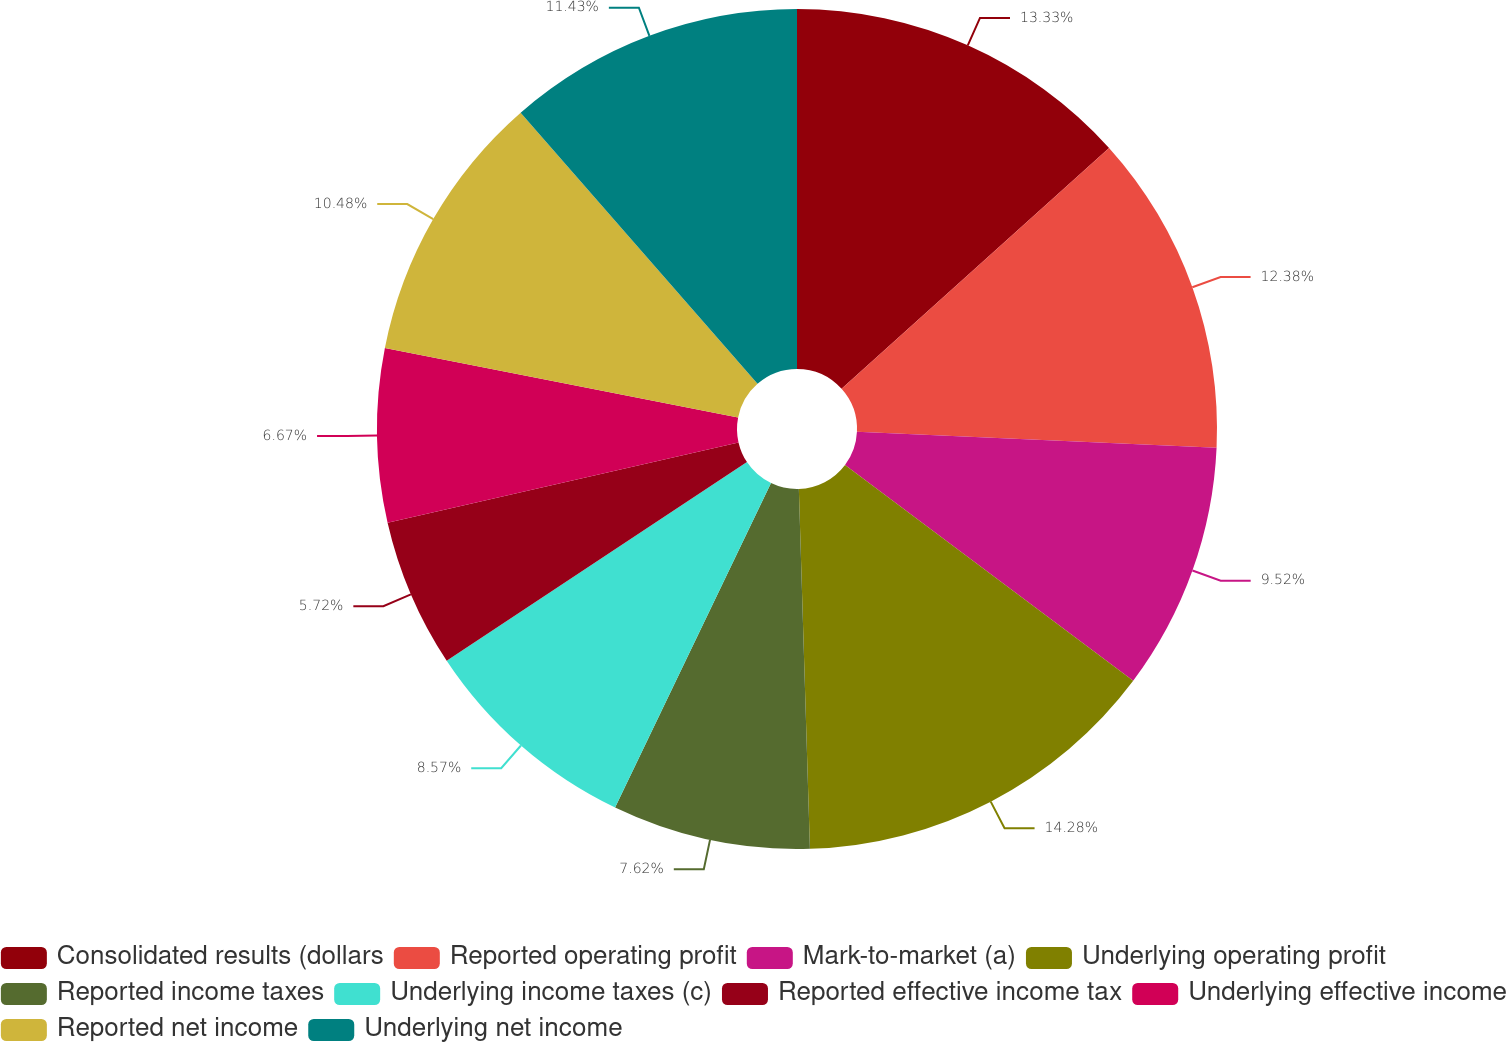Convert chart to OTSL. <chart><loc_0><loc_0><loc_500><loc_500><pie_chart><fcel>Consolidated results (dollars<fcel>Reported operating profit<fcel>Mark-to-market (a)<fcel>Underlying operating profit<fcel>Reported income taxes<fcel>Underlying income taxes (c)<fcel>Reported effective income tax<fcel>Underlying effective income<fcel>Reported net income<fcel>Underlying net income<nl><fcel>13.33%<fcel>12.38%<fcel>9.52%<fcel>14.28%<fcel>7.62%<fcel>8.57%<fcel>5.72%<fcel>6.67%<fcel>10.48%<fcel>11.43%<nl></chart> 